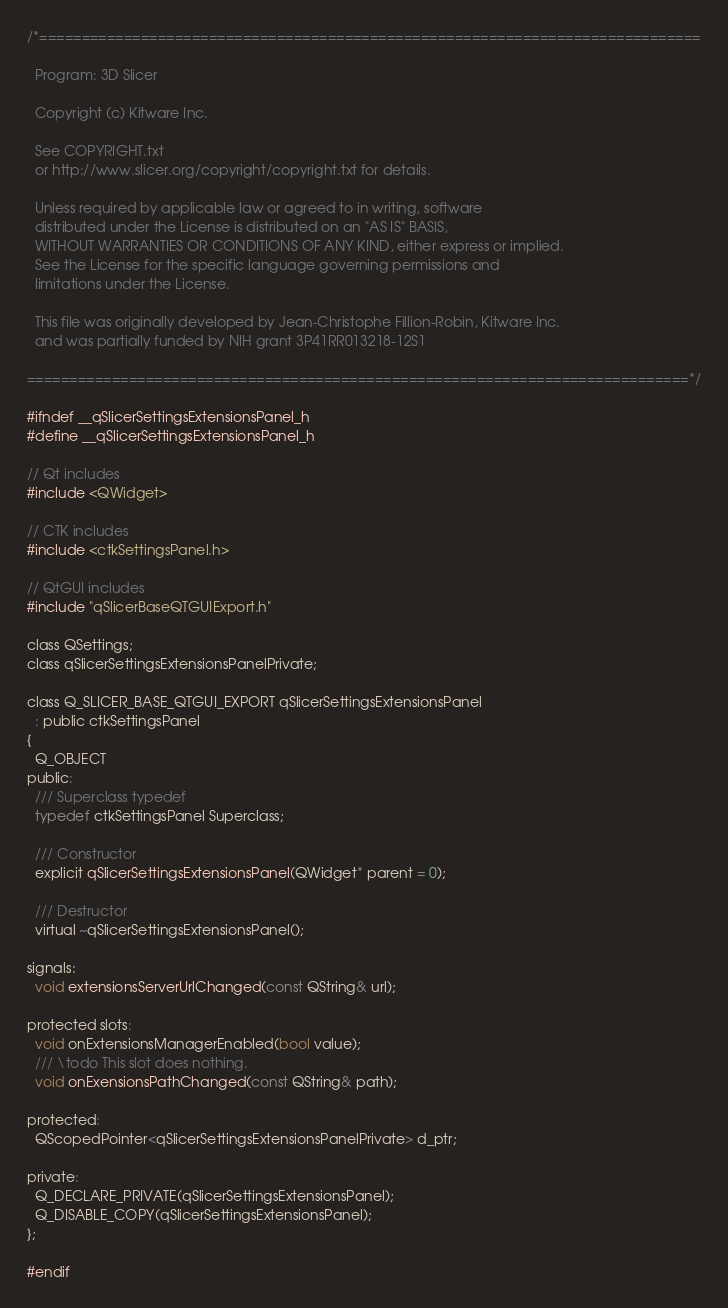Convert code to text. <code><loc_0><loc_0><loc_500><loc_500><_C_>/*==============================================================================

  Program: 3D Slicer

  Copyright (c) Kitware Inc.

  See COPYRIGHT.txt
  or http://www.slicer.org/copyright/copyright.txt for details.

  Unless required by applicable law or agreed to in writing, software
  distributed under the License is distributed on an "AS IS" BASIS,
  WITHOUT WARRANTIES OR CONDITIONS OF ANY KIND, either express or implied.
  See the License for the specific language governing permissions and
  limitations under the License.

  This file was originally developed by Jean-Christophe Fillion-Robin, Kitware Inc.
  and was partially funded by NIH grant 3P41RR013218-12S1

==============================================================================*/

#ifndef __qSlicerSettingsExtensionsPanel_h
#define __qSlicerSettingsExtensionsPanel_h

// Qt includes
#include <QWidget>

// CTK includes
#include <ctkSettingsPanel.h>

// QtGUI includes
#include "qSlicerBaseQTGUIExport.h"

class QSettings;
class qSlicerSettingsExtensionsPanelPrivate;

class Q_SLICER_BASE_QTGUI_EXPORT qSlicerSettingsExtensionsPanel
  : public ctkSettingsPanel
{
  Q_OBJECT
public:
  /// Superclass typedef
  typedef ctkSettingsPanel Superclass;

  /// Constructor
  explicit qSlicerSettingsExtensionsPanel(QWidget* parent = 0);

  /// Destructor
  virtual ~qSlicerSettingsExtensionsPanel();

signals:
  void extensionsServerUrlChanged(const QString& url);

protected slots:
  void onExtensionsManagerEnabled(bool value);
  /// \todo This slot does nothing.
  void onExensionsPathChanged(const QString& path);

protected:
  QScopedPointer<qSlicerSettingsExtensionsPanelPrivate> d_ptr;

private:
  Q_DECLARE_PRIVATE(qSlicerSettingsExtensionsPanel);
  Q_DISABLE_COPY(qSlicerSettingsExtensionsPanel);
};

#endif
</code> 